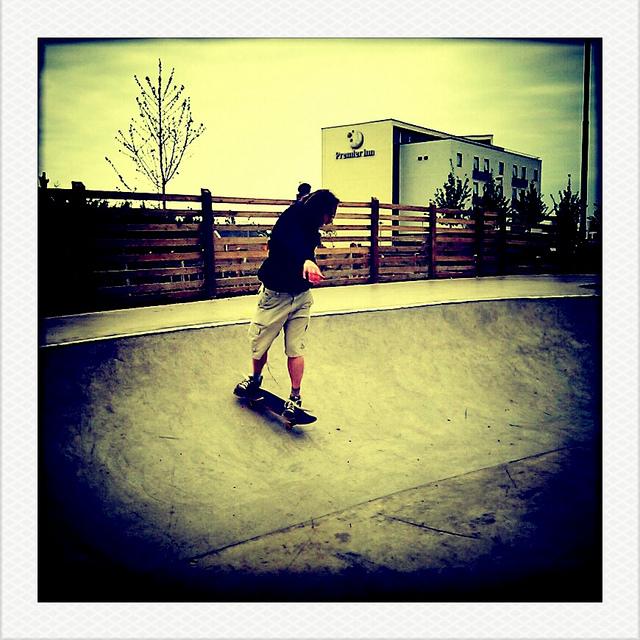How many trees are in this photo?
Concise answer only. 5. Is this picture taken with Instagram?
Be succinct. Yes. Do this person have fans?
Keep it brief. No. 